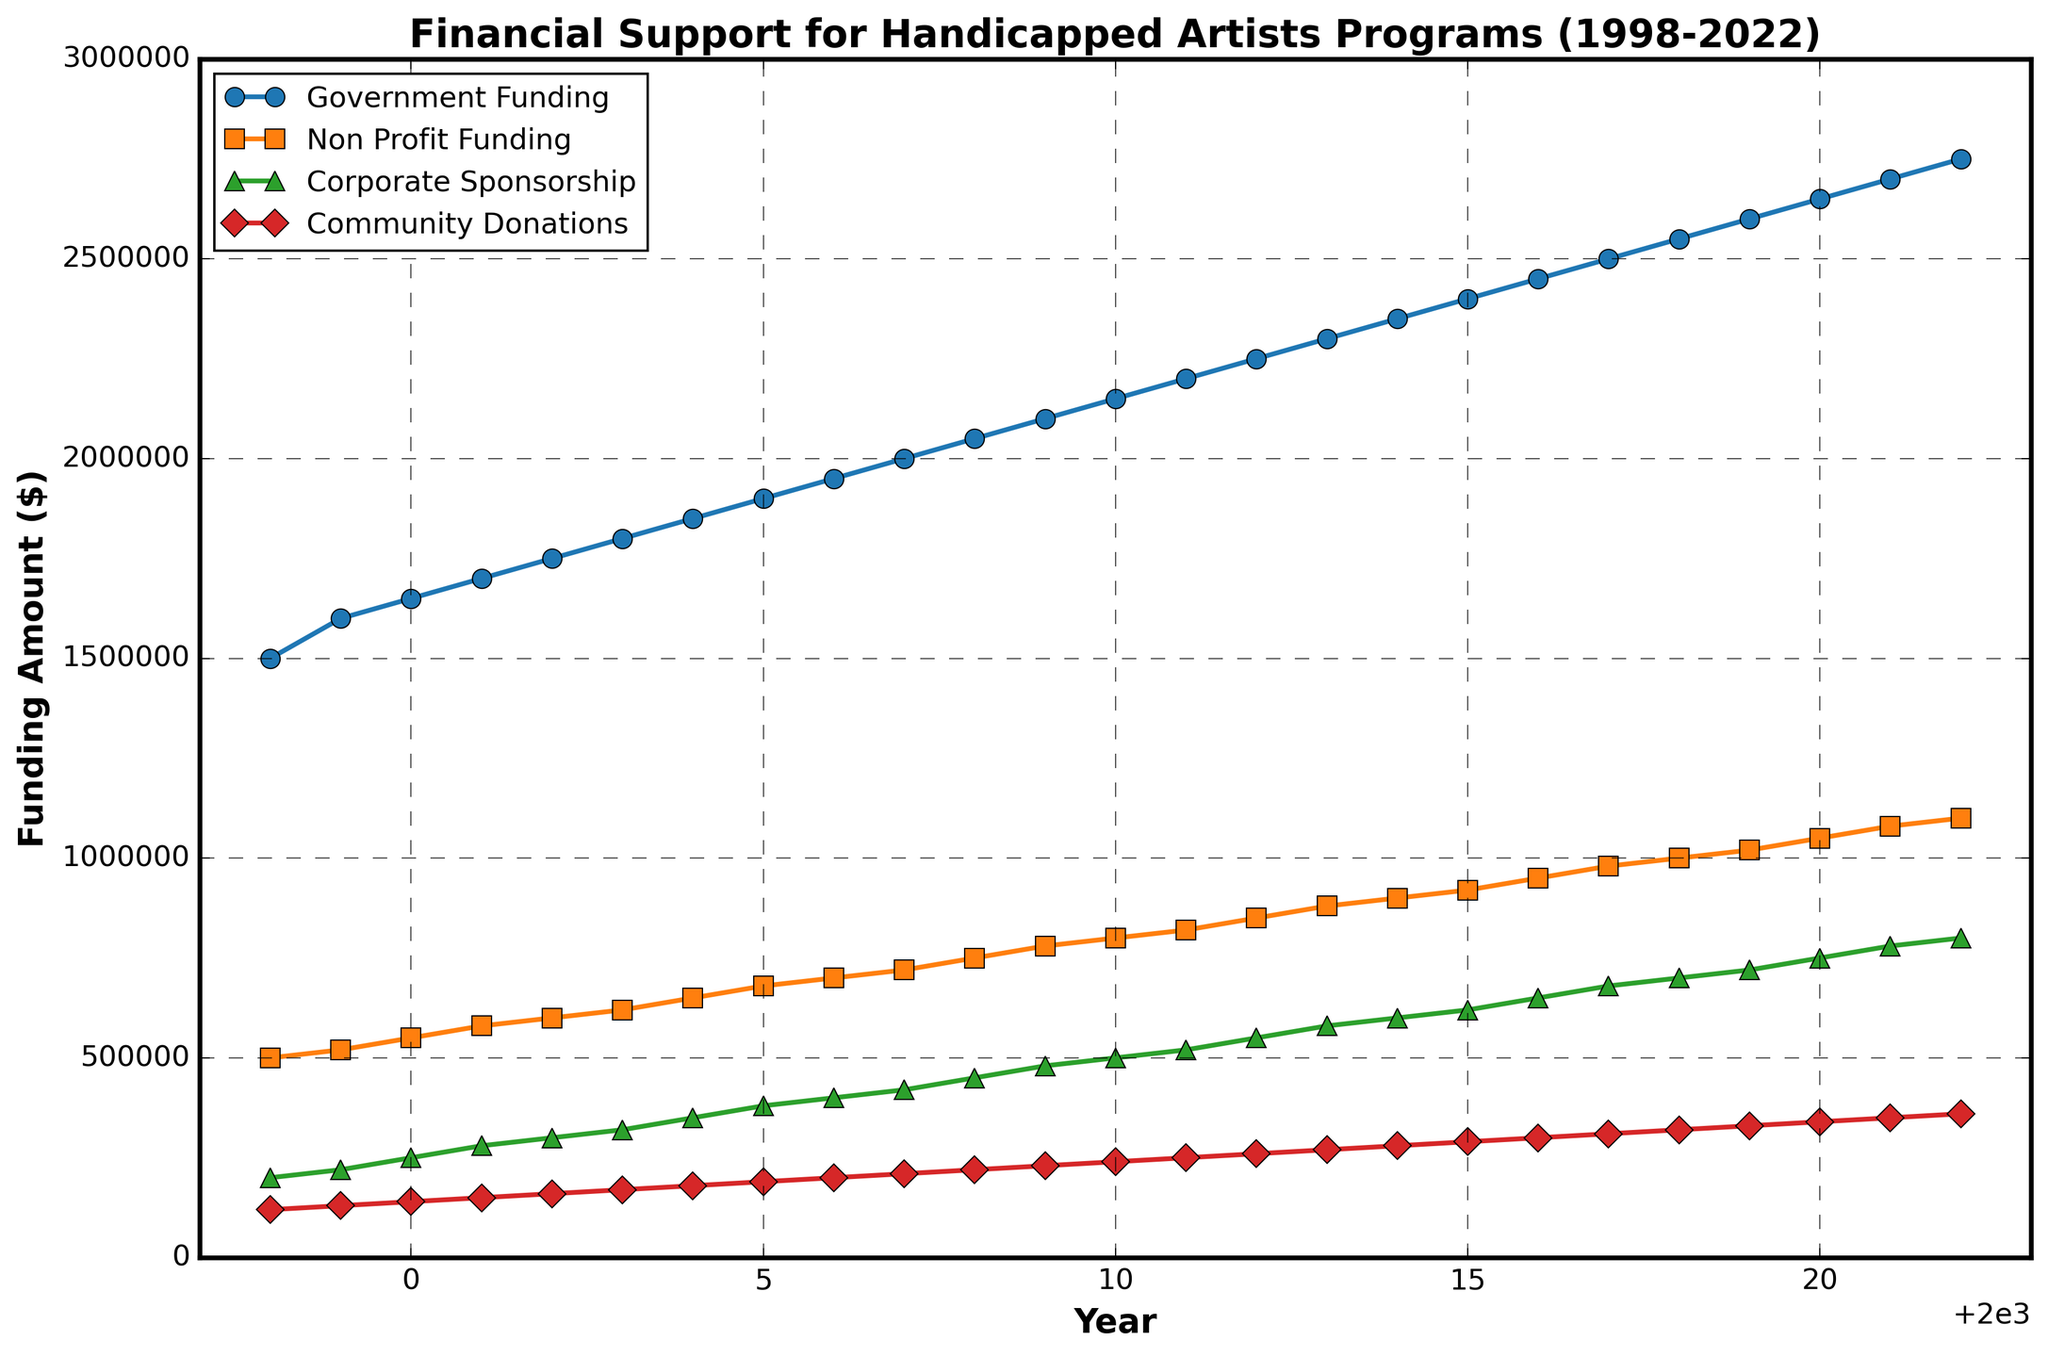What is the title of the figure? The title of the figure is located at the top and it describes the main subject of the plot. By reading the title, we learn what the plot is about. The title is "Financial Support for Handicapped Artists Programs (1998-2022)"
Answer: Financial Support for Handicapped Artists Programs (1998-2022) How many funding categories are tracked in the plot? By counting the distinct lines in the plot, which are labeled in the legend, we can determine the number of funding categories tracked. There are four lines, indicating four categories.
Answer: Four What is the general trend of Government Funding over the years? Observing the line corresponding to Government Funding, we see that it generally increases from left to right on the plot. This shows a positive trend where Government Funding consistently rises over the years.
Answer: Increasing Which year had the highest Community Donations and what was the amount? By locating the highest point on the Community Donations line (label and color help), we see it peaks in 2022. The y-axis value for this point is 360,000.
Answer: 2022, $360,000 By how much did the Non-Profit Funding increase from 1998 to 2022? To find the increase, subtract the Non-Profit Funding value in 1998 from the value in 2022. The amounts are $500,000 in 1998 and $1,100,000 in 2022. Calculation: $1,100,000 - $500,000 = $600,000.
Answer: $600,000 In what year did Corporate Sponsorship first reach $500,000? Look along the Corporate Sponsorship line (using its color and shape) to find the first occurrence of it reaching $500,000. This value is reached in 2010.
Answer: 2010 What was the total funding amount for all categories in 2020? To find the total funding amount, sum the funding amounts for all categories in 2020. Government Funding: $2,650,000, Non-Profit Funding: $1,050,000, Corporate Sponsorship: $750,000, Community Donations: $340,000. So, $2,650,000 + $1,050,000 + $750,000 + $340,000 = $4,790,000.
Answer: $4,790,000 Which funding category increased the most in absolute dollar amount over the 25 years? Calculate the difference between the initial and final amounts for each category: Government Funding ($2,750,000 - $1,500,000 = $1,250,000), Non-Profit Funding ($1,100,000 - $500,000 = $600,000), Corporate Sponsorship ($800,000 - $200,000 = $600,000), Community Donations ($360,000 - $120,000 = $240,000). The largest increase is in Government Funding.
Answer: Government Funding During which five-year period did Government Funding increase the most? Break down the increments: 1998-2002 ($175,000), 2002-2007 ($250,000), 2007-2012 ($250,000), 2012-2017 ($250,000), 2017-2022 ($250,000). Each of the periods 2002-2007, 2007-2012, 2012-2017, and 2017-2022 saw the highest increase of $250,000.
Answer: 2002-2007, 2007-2012, 2012-2017, 2017-2022 